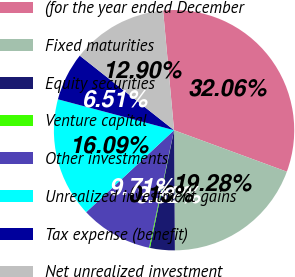<chart> <loc_0><loc_0><loc_500><loc_500><pie_chart><fcel>(for the year ended December<fcel>Fixed maturities<fcel>Equity securities<fcel>Venture capital<fcel>Other investments<fcel>Unrealized investment gains<fcel>Tax expense (benefit)<fcel>Net unrealized investment<nl><fcel>32.06%<fcel>19.28%<fcel>3.32%<fcel>0.13%<fcel>9.71%<fcel>16.09%<fcel>6.51%<fcel>12.9%<nl></chart> 